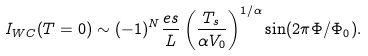Convert formula to latex. <formula><loc_0><loc_0><loc_500><loc_500>I _ { W C } ( T = 0 ) \sim ( - 1 ) ^ { N } \frac { e s } { L } \left ( \frac { T _ { s } } { \alpha V _ { 0 } } \right ) ^ { 1 / \alpha } \sin ( 2 \pi \Phi / \Phi _ { 0 } ) .</formula> 